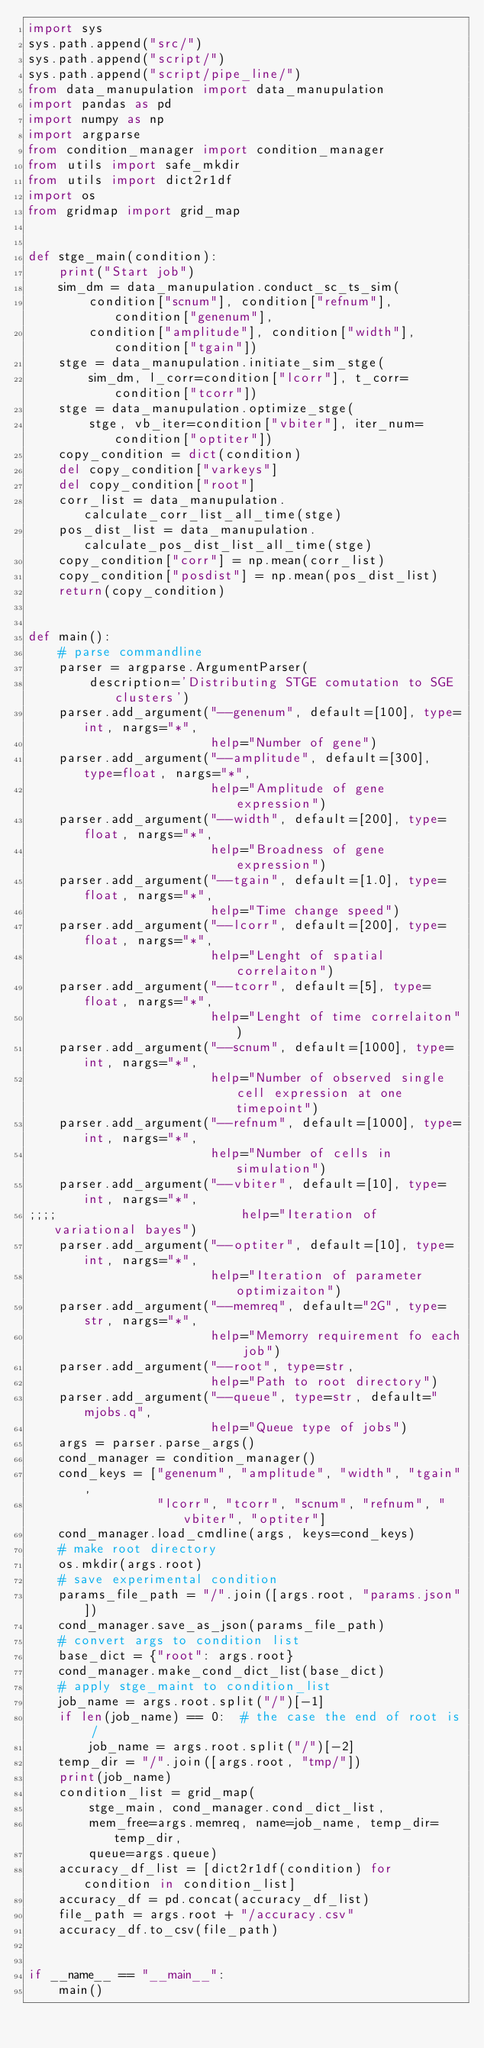Convert code to text. <code><loc_0><loc_0><loc_500><loc_500><_Python_>import sys
sys.path.append("src/")
sys.path.append("script/")
sys.path.append("script/pipe_line/")
from data_manupulation import data_manupulation
import pandas as pd
import numpy as np
import argparse
from condition_manager import condition_manager
from utils import safe_mkdir
from utils import dict2r1df
import os
from gridmap import grid_map


def stge_main(condition):
    print("Start job")
    sim_dm = data_manupulation.conduct_sc_ts_sim(
        condition["scnum"], condition["refnum"], condition["genenum"],
        condition["amplitude"], condition["width"], condition["tgain"])
    stge = data_manupulation.initiate_sim_stge(
        sim_dm, l_corr=condition["lcorr"], t_corr=condition["tcorr"])
    stge = data_manupulation.optimize_stge(
        stge, vb_iter=condition["vbiter"], iter_num=condition["optiter"])
    copy_condition = dict(condition)
    del copy_condition["varkeys"]
    del copy_condition["root"]
    corr_list = data_manupulation.calculate_corr_list_all_time(stge)
    pos_dist_list = data_manupulation.calculate_pos_dist_list_all_time(stge)
    copy_condition["corr"] = np.mean(corr_list)
    copy_condition["posdist"] = np.mean(pos_dist_list)
    return(copy_condition)


def main():
    # parse commandline
    parser = argparse.ArgumentParser(
        description='Distributing STGE comutation to SGE clusters')
    parser.add_argument("--genenum", default=[100], type=int, nargs="*",
                        help="Number of gene")
    parser.add_argument("--amplitude", default=[300], type=float, nargs="*",
                        help="Amplitude of gene expression")
    parser.add_argument("--width", default=[200], type=float, nargs="*",
                        help="Broadness of gene expression")
    parser.add_argument("--tgain", default=[1.0], type=float, nargs="*",
                        help="Time change speed")
    parser.add_argument("--lcorr", default=[200], type=float, nargs="*",
                        help="Lenght of spatial correlaiton")
    parser.add_argument("--tcorr", default=[5], type=float, nargs="*",
                        help="Lenght of time correlaiton")
    parser.add_argument("--scnum", default=[1000], type=int, nargs="*",
                        help="Number of observed single cell expression at one timepoint")
    parser.add_argument("--refnum", default=[1000], type=int, nargs="*",
                        help="Number of cells in simulation")
    parser.add_argument("--vbiter", default=[10], type=int, nargs="*",
;;;;                        help="Iteration of variational bayes")
    parser.add_argument("--optiter", default=[10], type=int, nargs="*",
                        help="Iteration of parameter optimizaiton")
    parser.add_argument("--memreq", default="2G", type=str, nargs="*",
                        help="Memorry requirement fo each job")
    parser.add_argument("--root", type=str,
                        help="Path to root directory")
    parser.add_argument("--queue", type=str, default="mjobs.q",
                        help="Queue type of jobs")
    args = parser.parse_args()
    cond_manager = condition_manager()
    cond_keys = ["genenum", "amplitude", "width", "tgain",
                 "lcorr", "tcorr", "scnum", "refnum", "vbiter", "optiter"]
    cond_manager.load_cmdline(args, keys=cond_keys)
    # make root directory
    os.mkdir(args.root)
    # save experimental condition
    params_file_path = "/".join([args.root, "params.json"])
    cond_manager.save_as_json(params_file_path)
    # convert args to condition list
    base_dict = {"root": args.root}
    cond_manager.make_cond_dict_list(base_dict)
    # apply stge_maint to condition_list
    job_name = args.root.split("/")[-1]
    if len(job_name) == 0:  # the case the end of root is /
        job_name = args.root.split("/")[-2]
    temp_dir = "/".join([args.root, "tmp/"])
    print(job_name)
    condition_list = grid_map(
        stge_main, cond_manager.cond_dict_list,
        mem_free=args.memreq, name=job_name, temp_dir=temp_dir,
        queue=args.queue)
    accuracy_df_list = [dict2r1df(condition) for condition in condition_list]
    accuracy_df = pd.concat(accuracy_df_list)
    file_path = args.root + "/accuracy.csv"
    accuracy_df.to_csv(file_path)


if __name__ == "__main__":
    main()
</code> 